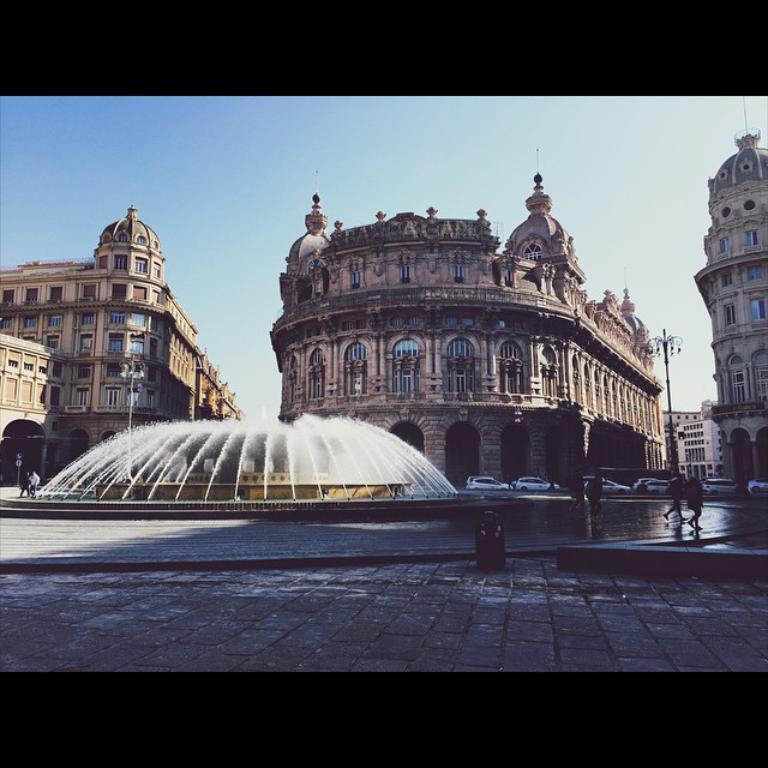How would you summarize this image in a sentence or two? In this image we can see buildings, cars, fountain. At the bottom of the image there is floor. At top of the image there is sky. 